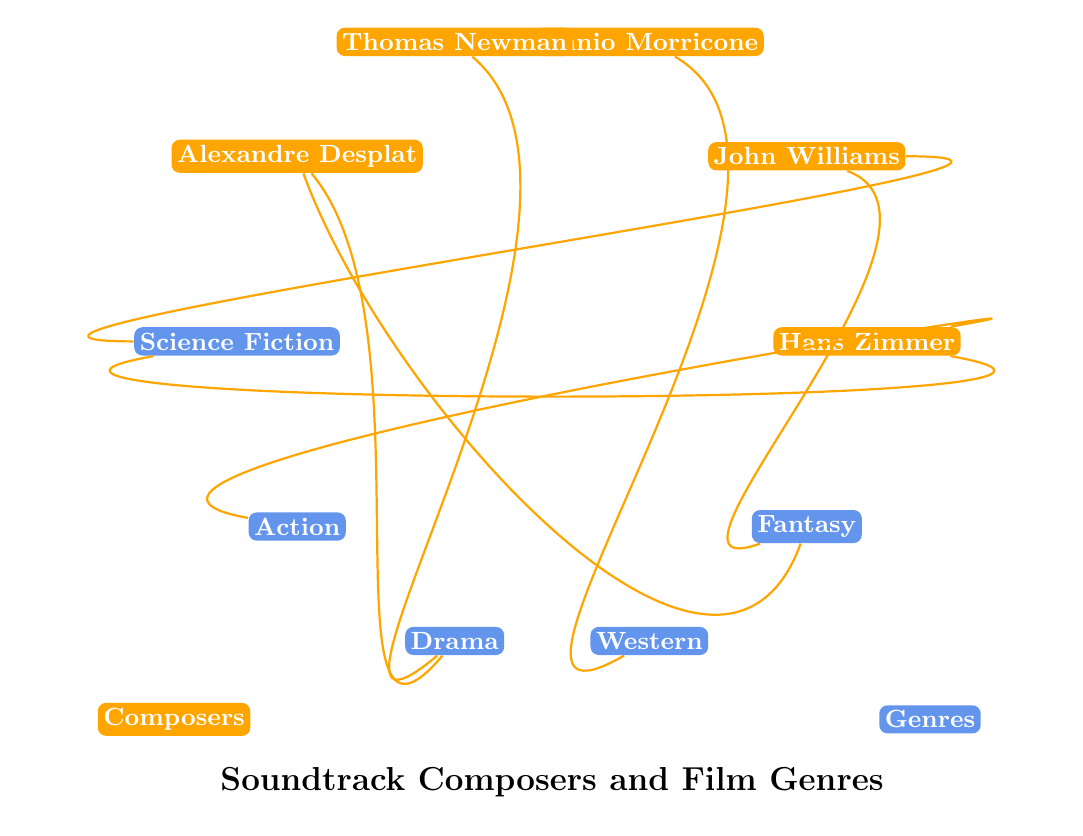What genres does Hans Zimmer compose for? By checking the diagram, Hans Zimmer is connected to the genres Science Fiction and Action, which indicates the types of films he specializes in composing for.
Answer: Science Fiction, Action How many composers are represented in the diagram? The diagram includes five composer nodes: Hans Zimmer, John Williams, Ennio Morricone, Thomas Newman, and Alexandre Desplat. Counting these nodes gives the total number of composers.
Answer: 5 Which composer is associated with the genre Drama? The diagram shows connections from both Thomas Newman and Alexandre Desplat to the Drama genre, indicating that both specialize in composing for this type of film.
Answer: Thomas Newman, Alexandre Desplat What is the maximum number of genres a single composer is associated with? By looking at the connections in the diagram, John Williams is associated with two genres (Science Fiction and Fantasy), and all other composers are also connected to a maximum of two genres each, making the maximum two.
Answer: 2 Which composer is linked to the most genres? Each of the composers in the diagram is connected to either one or two genres, but no single composer has more than two connections. Thus, the answer is that no one exceeds two connections, and multiple composers tie for the highest number.
Answer: Multiple composers Is there a composer associated with the Western genre? The diagram shows that Ennio Morricone has a connection to the Western genre, indicating his specialization in that style of film.
Answer: Ennio Morricone How many total relationships between composers and genres are shown in the diagram? By tallying the connections represented in the diagram, we see that there are eight relationships linking the composers to their respective genres.
Answer: 8 Does Alexandre Desplat compose for the Action genre? The diagram indicates a connection only between Alexandre Desplat and the Drama and Fantasy genres, with no link to the Action genre, leading to the conclusion.
Answer: No 